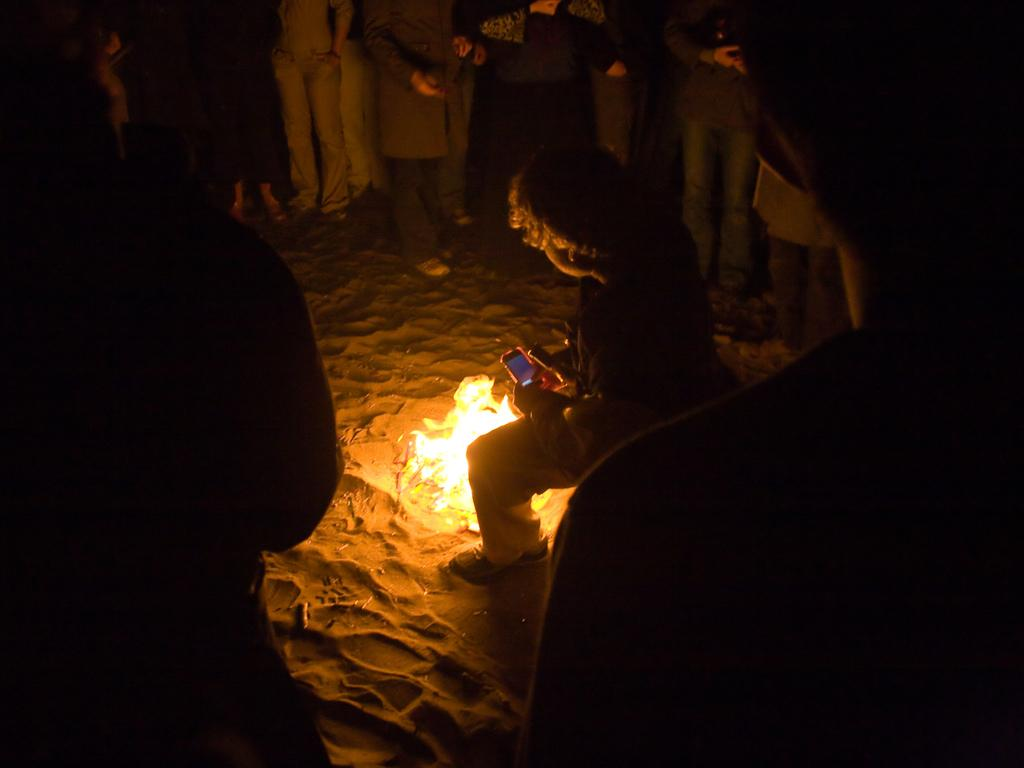What is the surface on which the people are standing in the image? The people are standing on the sand. What can be seen at the center of the image? There is a fire at the center of the image. Can you describe the person holding an object in the image? A person is present holding a mobile phone. What type of magic is being performed by the person holding the mobile phone in the image? There is no indication of magic or any magical activity in the image. What ingredients are being used to prepare the stew in the image? There is no stew present in the image. 